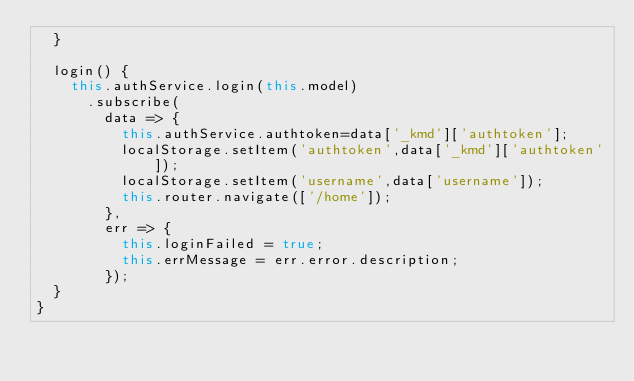<code> <loc_0><loc_0><loc_500><loc_500><_TypeScript_>  }

  login() {
    this.authService.login(this.model)
      .subscribe(
        data => {
          this.authService.authtoken=data['_kmd']['authtoken'];
          localStorage.setItem('authtoken',data['_kmd']['authtoken']);
          localStorage.setItem('username',data['username']);
          this.router.navigate(['/home']);
        },
        err => {
          this.loginFailed = true;
          this.errMessage = err.error.description;
        });
  }
}
</code> 